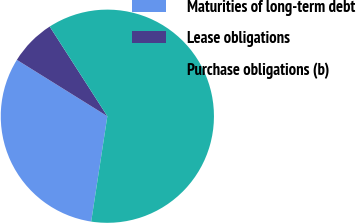<chart> <loc_0><loc_0><loc_500><loc_500><pie_chart><fcel>Maturities of long-term debt<fcel>Lease obligations<fcel>Purchase obligations (b)<nl><fcel>31.44%<fcel>7.04%<fcel>61.51%<nl></chart> 